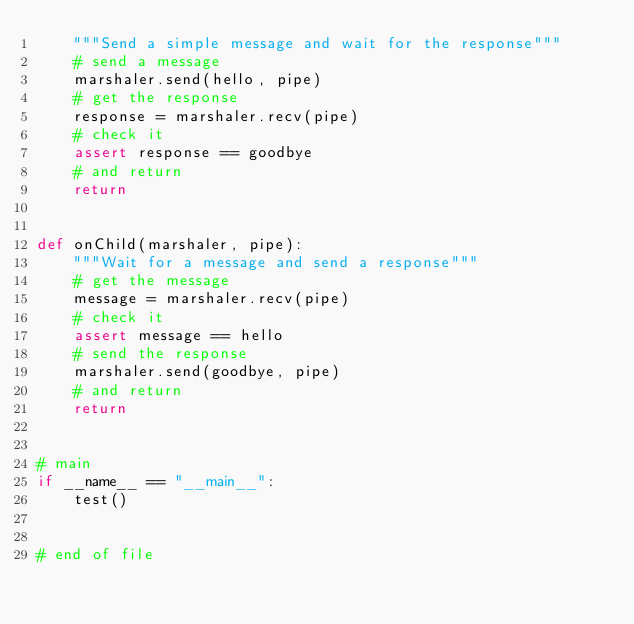Convert code to text. <code><loc_0><loc_0><loc_500><loc_500><_Python_>    """Send a simple message and wait for the response"""
    # send a message
    marshaler.send(hello, pipe)
    # get the response
    response = marshaler.recv(pipe)
    # check it
    assert response == goodbye
    # and return
    return


def onChild(marshaler, pipe):
    """Wait for a message and send a response"""
    # get the message
    message = marshaler.recv(pipe)
    # check it
    assert message == hello
    # send the response
    marshaler.send(goodbye, pipe)
    # and return
    return


# main
if __name__ == "__main__":
    test()


# end of file
</code> 